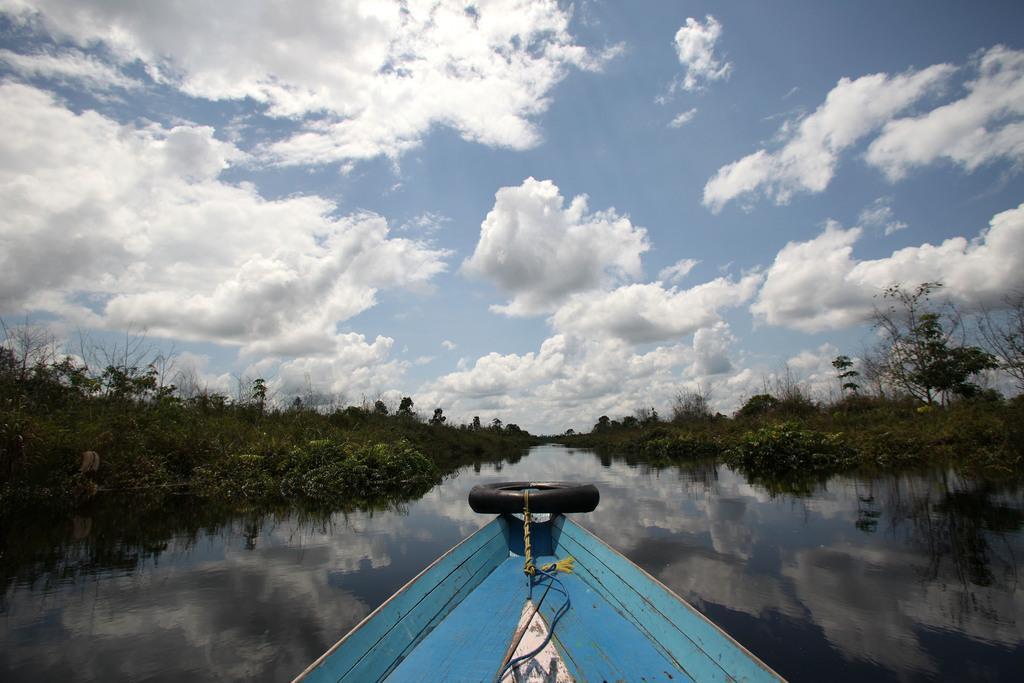In one or two sentences, can you explain what this image depicts? This picture might be taken from outside of the city. In this image, in the middle, we can see a port which is drowning on the water, on that boat, we can see a tyre. On the right side, we can see some tree and plants. On the left side, we can also see some trees and plants. At the top, we can see a sky, at the bottom, we can see a water in a lake. 